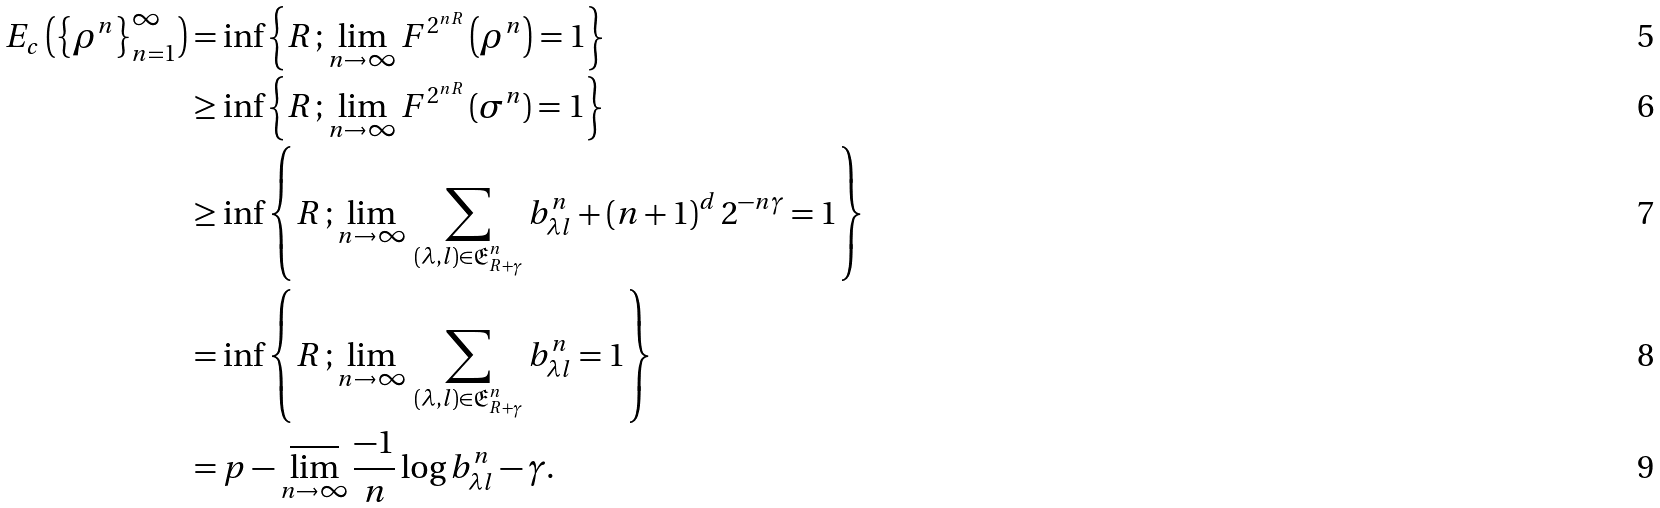Convert formula to latex. <formula><loc_0><loc_0><loc_500><loc_500>E _ { c } \left ( \left \{ \rho ^ { n } \right \} _ { n = 1 } ^ { \infty } \right ) & = \inf \left \{ R \, ; \lim _ { n \rightarrow \infty } F ^ { 2 ^ { n R } } \left ( \rho ^ { n } \right ) = 1 \right \} \\ & \geq \inf \left \{ R \, ; \lim _ { n \rightarrow \infty } F ^ { 2 ^ { n R } } \left ( \sigma ^ { n } \right ) = 1 \right \} \\ & \geq \inf \left \{ R \, ; \lim _ { n \rightarrow \infty } \, \sum _ { \left ( \lambda , l \right ) \in \mathfrak { E } _ { R + \gamma } ^ { n } } b _ { \lambda l } ^ { n } + \left ( n + 1 \right ) ^ { d } 2 ^ { - n \gamma } = 1 \right \} \\ & = \inf \left \{ R \, ; \lim _ { n \rightarrow \infty } \, \sum _ { \left ( \lambda , l \right ) \in \mathfrak { E } _ { R + \gamma } ^ { n } } b _ { \lambda l } ^ { n } = 1 \right \} \\ & = p - \varlimsup _ { n \rightarrow \infty } \frac { - 1 } { n } \log b _ { \lambda l } ^ { n } - \gamma .</formula> 